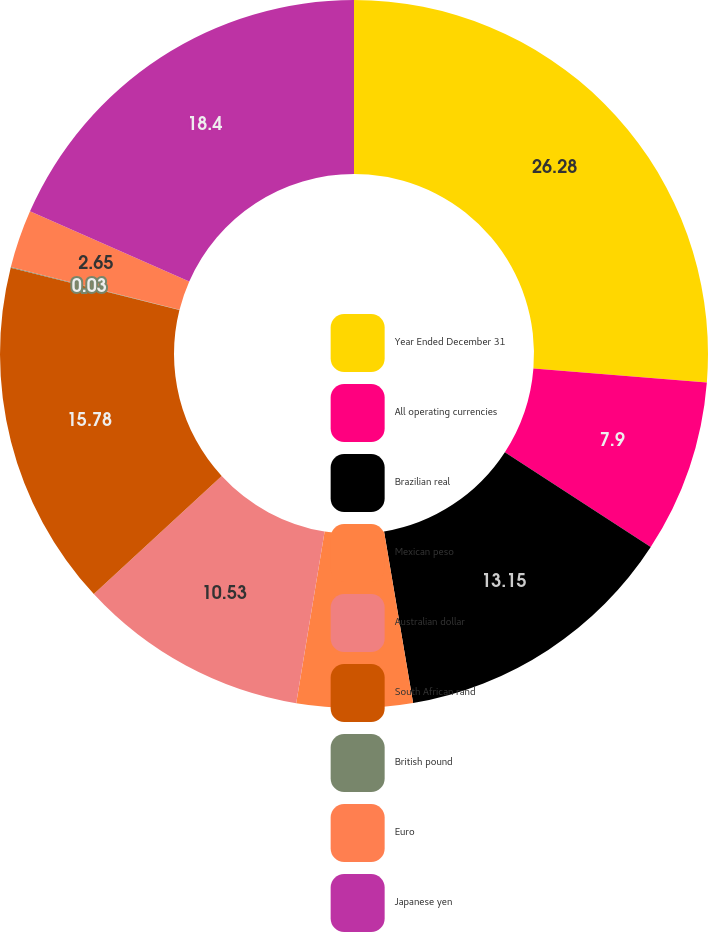<chart> <loc_0><loc_0><loc_500><loc_500><pie_chart><fcel>Year Ended December 31<fcel>All operating currencies<fcel>Brazilian real<fcel>Mexican peso<fcel>Australian dollar<fcel>South African rand<fcel>British pound<fcel>Euro<fcel>Japanese yen<nl><fcel>26.28%<fcel>7.9%<fcel>13.15%<fcel>5.28%<fcel>10.53%<fcel>15.78%<fcel>0.03%<fcel>2.65%<fcel>18.4%<nl></chart> 